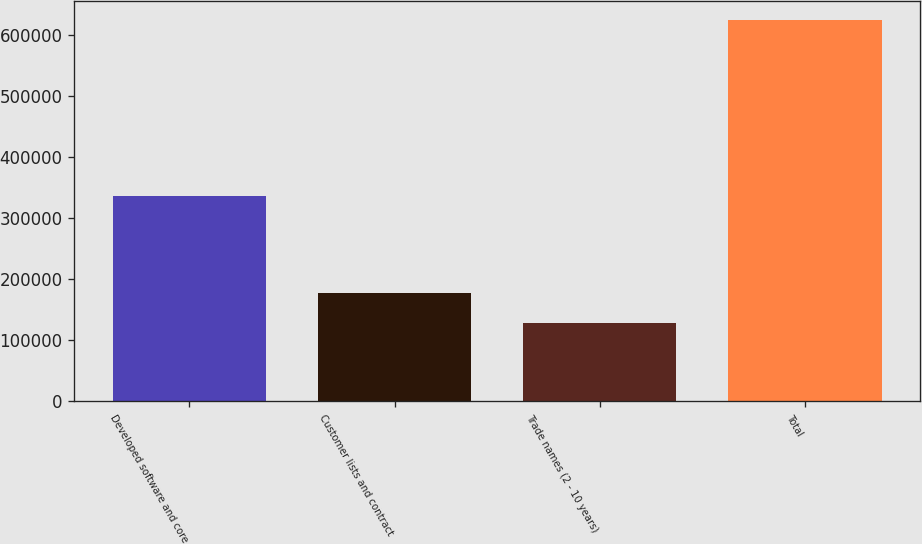Convert chart. <chart><loc_0><loc_0><loc_500><loc_500><bar_chart><fcel>Developed software and core<fcel>Customer lists and contract<fcel>Trade names (2 - 10 years)<fcel>Total<nl><fcel>336262<fcel>177518<fcel>127903<fcel>624050<nl></chart> 